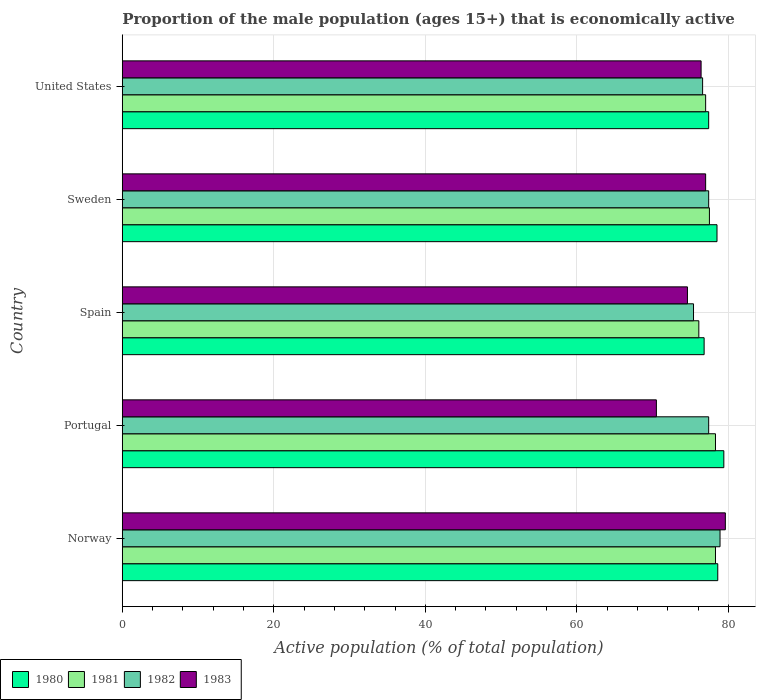How many groups of bars are there?
Offer a very short reply. 5. Are the number of bars per tick equal to the number of legend labels?
Ensure brevity in your answer.  Yes. How many bars are there on the 1st tick from the bottom?
Provide a short and direct response. 4. What is the proportion of the male population that is economically active in 1980 in Portugal?
Your response must be concise. 79.4. Across all countries, what is the maximum proportion of the male population that is economically active in 1981?
Provide a short and direct response. 78.3. Across all countries, what is the minimum proportion of the male population that is economically active in 1980?
Your answer should be compact. 76.8. In which country was the proportion of the male population that is economically active in 1981 maximum?
Ensure brevity in your answer.  Norway. What is the total proportion of the male population that is economically active in 1982 in the graph?
Give a very brief answer. 385.7. What is the difference between the proportion of the male population that is economically active in 1981 in Portugal and that in Spain?
Keep it short and to the point. 2.2. What is the difference between the proportion of the male population that is economically active in 1982 in Norway and the proportion of the male population that is economically active in 1983 in Spain?
Offer a terse response. 4.3. What is the average proportion of the male population that is economically active in 1981 per country?
Offer a very short reply. 77.44. What is the difference between the proportion of the male population that is economically active in 1980 and proportion of the male population that is economically active in 1982 in Sweden?
Keep it short and to the point. 1.1. In how many countries, is the proportion of the male population that is economically active in 1983 greater than 20 %?
Provide a short and direct response. 5. What is the ratio of the proportion of the male population that is economically active in 1980 in Spain to that in United States?
Your answer should be very brief. 0.99. Is the proportion of the male population that is economically active in 1980 in Norway less than that in Spain?
Keep it short and to the point. No. What is the difference between the highest and the second highest proportion of the male population that is economically active in 1982?
Make the answer very short. 1.5. Is the sum of the proportion of the male population that is economically active in 1980 in Norway and Spain greater than the maximum proportion of the male population that is economically active in 1981 across all countries?
Offer a terse response. Yes. Is it the case that in every country, the sum of the proportion of the male population that is economically active in 1982 and proportion of the male population that is economically active in 1983 is greater than the sum of proportion of the male population that is economically active in 1981 and proportion of the male population that is economically active in 1980?
Give a very brief answer. No. What does the 4th bar from the bottom in Norway represents?
Offer a very short reply. 1983. How many countries are there in the graph?
Provide a succinct answer. 5. What is the difference between two consecutive major ticks on the X-axis?
Ensure brevity in your answer.  20. Are the values on the major ticks of X-axis written in scientific E-notation?
Your answer should be very brief. No. Does the graph contain any zero values?
Provide a short and direct response. No. Where does the legend appear in the graph?
Your answer should be very brief. Bottom left. How many legend labels are there?
Offer a very short reply. 4. What is the title of the graph?
Your answer should be very brief. Proportion of the male population (ages 15+) that is economically active. What is the label or title of the X-axis?
Keep it short and to the point. Active population (% of total population). What is the Active population (% of total population) of 1980 in Norway?
Your answer should be compact. 78.6. What is the Active population (% of total population) in 1981 in Norway?
Provide a short and direct response. 78.3. What is the Active population (% of total population) in 1982 in Norway?
Offer a terse response. 78.9. What is the Active population (% of total population) of 1983 in Norway?
Your answer should be very brief. 79.6. What is the Active population (% of total population) of 1980 in Portugal?
Offer a very short reply. 79.4. What is the Active population (% of total population) of 1981 in Portugal?
Make the answer very short. 78.3. What is the Active population (% of total population) of 1982 in Portugal?
Offer a very short reply. 77.4. What is the Active population (% of total population) in 1983 in Portugal?
Provide a succinct answer. 70.5. What is the Active population (% of total population) in 1980 in Spain?
Your answer should be compact. 76.8. What is the Active population (% of total population) of 1981 in Spain?
Keep it short and to the point. 76.1. What is the Active population (% of total population) of 1982 in Spain?
Offer a very short reply. 75.4. What is the Active population (% of total population) of 1983 in Spain?
Offer a terse response. 74.6. What is the Active population (% of total population) in 1980 in Sweden?
Keep it short and to the point. 78.5. What is the Active population (% of total population) of 1981 in Sweden?
Keep it short and to the point. 77.5. What is the Active population (% of total population) in 1982 in Sweden?
Keep it short and to the point. 77.4. What is the Active population (% of total population) of 1983 in Sweden?
Keep it short and to the point. 77. What is the Active population (% of total population) of 1980 in United States?
Your response must be concise. 77.4. What is the Active population (% of total population) in 1981 in United States?
Offer a terse response. 77. What is the Active population (% of total population) in 1982 in United States?
Your answer should be compact. 76.6. What is the Active population (% of total population) of 1983 in United States?
Make the answer very short. 76.4. Across all countries, what is the maximum Active population (% of total population) in 1980?
Keep it short and to the point. 79.4. Across all countries, what is the maximum Active population (% of total population) in 1981?
Provide a short and direct response. 78.3. Across all countries, what is the maximum Active population (% of total population) of 1982?
Offer a very short reply. 78.9. Across all countries, what is the maximum Active population (% of total population) of 1983?
Give a very brief answer. 79.6. Across all countries, what is the minimum Active population (% of total population) in 1980?
Keep it short and to the point. 76.8. Across all countries, what is the minimum Active population (% of total population) in 1981?
Your answer should be very brief. 76.1. Across all countries, what is the minimum Active population (% of total population) in 1982?
Give a very brief answer. 75.4. Across all countries, what is the minimum Active population (% of total population) of 1983?
Keep it short and to the point. 70.5. What is the total Active population (% of total population) in 1980 in the graph?
Your response must be concise. 390.7. What is the total Active population (% of total population) in 1981 in the graph?
Keep it short and to the point. 387.2. What is the total Active population (% of total population) in 1982 in the graph?
Your answer should be very brief. 385.7. What is the total Active population (% of total population) of 1983 in the graph?
Provide a short and direct response. 378.1. What is the difference between the Active population (% of total population) in 1980 in Norway and that in Portugal?
Offer a very short reply. -0.8. What is the difference between the Active population (% of total population) of 1981 in Norway and that in Portugal?
Offer a terse response. 0. What is the difference between the Active population (% of total population) in 1982 in Norway and that in Portugal?
Give a very brief answer. 1.5. What is the difference between the Active population (% of total population) in 1982 in Norway and that in Spain?
Make the answer very short. 3.5. What is the difference between the Active population (% of total population) in 1983 in Norway and that in Spain?
Provide a succinct answer. 5. What is the difference between the Active population (% of total population) of 1980 in Norway and that in Sweden?
Provide a succinct answer. 0.1. What is the difference between the Active population (% of total population) in 1981 in Norway and that in Sweden?
Make the answer very short. 0.8. What is the difference between the Active population (% of total population) in 1982 in Norway and that in Sweden?
Your answer should be compact. 1.5. What is the difference between the Active population (% of total population) in 1983 in Norway and that in Sweden?
Your answer should be compact. 2.6. What is the difference between the Active population (% of total population) in 1981 in Norway and that in United States?
Offer a very short reply. 1.3. What is the difference between the Active population (% of total population) in 1983 in Norway and that in United States?
Your answer should be very brief. 3.2. What is the difference between the Active population (% of total population) of 1980 in Portugal and that in Spain?
Your answer should be compact. 2.6. What is the difference between the Active population (% of total population) of 1981 in Portugal and that in Sweden?
Your answer should be compact. 0.8. What is the difference between the Active population (% of total population) in 1983 in Portugal and that in Sweden?
Provide a succinct answer. -6.5. What is the difference between the Active population (% of total population) of 1980 in Portugal and that in United States?
Your answer should be very brief. 2. What is the difference between the Active population (% of total population) of 1981 in Portugal and that in United States?
Provide a succinct answer. 1.3. What is the difference between the Active population (% of total population) in 1982 in Portugal and that in United States?
Provide a short and direct response. 0.8. What is the difference between the Active population (% of total population) of 1982 in Spain and that in Sweden?
Make the answer very short. -2. What is the difference between the Active population (% of total population) in 1980 in Spain and that in United States?
Give a very brief answer. -0.6. What is the difference between the Active population (% of total population) of 1981 in Spain and that in United States?
Make the answer very short. -0.9. What is the difference between the Active population (% of total population) of 1981 in Sweden and that in United States?
Keep it short and to the point. 0.5. What is the difference between the Active population (% of total population) in 1980 in Norway and the Active population (% of total population) in 1982 in Portugal?
Your answer should be compact. 1.2. What is the difference between the Active population (% of total population) in 1981 in Norway and the Active population (% of total population) in 1982 in Portugal?
Your answer should be compact. 0.9. What is the difference between the Active population (% of total population) of 1981 in Norway and the Active population (% of total population) of 1983 in Portugal?
Offer a very short reply. 7.8. What is the difference between the Active population (% of total population) of 1980 in Norway and the Active population (% of total population) of 1981 in Spain?
Your response must be concise. 2.5. What is the difference between the Active population (% of total population) of 1980 in Norway and the Active population (% of total population) of 1983 in Spain?
Your answer should be compact. 4. What is the difference between the Active population (% of total population) of 1981 in Norway and the Active population (% of total population) of 1983 in Spain?
Make the answer very short. 3.7. What is the difference between the Active population (% of total population) of 1980 in Norway and the Active population (% of total population) of 1982 in Sweden?
Your answer should be very brief. 1.2. What is the difference between the Active population (% of total population) of 1981 in Norway and the Active population (% of total population) of 1983 in Sweden?
Provide a short and direct response. 1.3. What is the difference between the Active population (% of total population) in 1980 in Norway and the Active population (% of total population) in 1981 in United States?
Offer a very short reply. 1.6. What is the difference between the Active population (% of total population) of 1980 in Norway and the Active population (% of total population) of 1982 in United States?
Offer a very short reply. 2. What is the difference between the Active population (% of total population) of 1980 in Norway and the Active population (% of total population) of 1983 in United States?
Your answer should be compact. 2.2. What is the difference between the Active population (% of total population) of 1981 in Norway and the Active population (% of total population) of 1983 in United States?
Provide a short and direct response. 1.9. What is the difference between the Active population (% of total population) of 1980 in Portugal and the Active population (% of total population) of 1981 in Spain?
Your response must be concise. 3.3. What is the difference between the Active population (% of total population) of 1980 in Portugal and the Active population (% of total population) of 1982 in Spain?
Give a very brief answer. 4. What is the difference between the Active population (% of total population) of 1980 in Portugal and the Active population (% of total population) of 1981 in Sweden?
Give a very brief answer. 1.9. What is the difference between the Active population (% of total population) in 1980 in Portugal and the Active population (% of total population) in 1983 in Sweden?
Ensure brevity in your answer.  2.4. What is the difference between the Active population (% of total population) of 1981 in Portugal and the Active population (% of total population) of 1983 in Sweden?
Your answer should be compact. 1.3. What is the difference between the Active population (% of total population) of 1982 in Portugal and the Active population (% of total population) of 1983 in Sweden?
Your response must be concise. 0.4. What is the difference between the Active population (% of total population) in 1980 in Portugal and the Active population (% of total population) in 1981 in United States?
Give a very brief answer. 2.4. What is the difference between the Active population (% of total population) of 1980 in Portugal and the Active population (% of total population) of 1982 in United States?
Provide a short and direct response. 2.8. What is the difference between the Active population (% of total population) in 1980 in Portugal and the Active population (% of total population) in 1983 in United States?
Provide a short and direct response. 3. What is the difference between the Active population (% of total population) in 1981 in Portugal and the Active population (% of total population) in 1982 in United States?
Offer a terse response. 1.7. What is the difference between the Active population (% of total population) of 1980 in Spain and the Active population (% of total population) of 1982 in Sweden?
Keep it short and to the point. -0.6. What is the difference between the Active population (% of total population) in 1981 in Spain and the Active population (% of total population) in 1982 in Sweden?
Provide a succinct answer. -1.3. What is the difference between the Active population (% of total population) of 1981 in Spain and the Active population (% of total population) of 1983 in Sweden?
Make the answer very short. -0.9. What is the difference between the Active population (% of total population) in 1982 in Spain and the Active population (% of total population) in 1983 in Sweden?
Make the answer very short. -1.6. What is the difference between the Active population (% of total population) in 1980 in Spain and the Active population (% of total population) in 1983 in United States?
Give a very brief answer. 0.4. What is the difference between the Active population (% of total population) in 1981 in Spain and the Active population (% of total population) in 1982 in United States?
Provide a succinct answer. -0.5. What is the difference between the Active population (% of total population) in 1980 in Sweden and the Active population (% of total population) in 1983 in United States?
Your answer should be very brief. 2.1. What is the difference between the Active population (% of total population) of 1981 in Sweden and the Active population (% of total population) of 1982 in United States?
Provide a short and direct response. 0.9. What is the difference between the Active population (% of total population) of 1982 in Sweden and the Active population (% of total population) of 1983 in United States?
Keep it short and to the point. 1. What is the average Active population (% of total population) in 1980 per country?
Provide a short and direct response. 78.14. What is the average Active population (% of total population) in 1981 per country?
Provide a succinct answer. 77.44. What is the average Active population (% of total population) of 1982 per country?
Ensure brevity in your answer.  77.14. What is the average Active population (% of total population) in 1983 per country?
Ensure brevity in your answer.  75.62. What is the difference between the Active population (% of total population) of 1980 and Active population (% of total population) of 1983 in Norway?
Your answer should be very brief. -1. What is the difference between the Active population (% of total population) in 1981 and Active population (% of total population) in 1982 in Norway?
Provide a short and direct response. -0.6. What is the difference between the Active population (% of total population) of 1981 and Active population (% of total population) of 1983 in Norway?
Provide a succinct answer. -1.3. What is the difference between the Active population (% of total population) in 1980 and Active population (% of total population) in 1981 in Portugal?
Your response must be concise. 1.1. What is the difference between the Active population (% of total population) in 1980 and Active population (% of total population) in 1983 in Portugal?
Provide a short and direct response. 8.9. What is the difference between the Active population (% of total population) of 1981 and Active population (% of total population) of 1982 in Portugal?
Ensure brevity in your answer.  0.9. What is the difference between the Active population (% of total population) in 1981 and Active population (% of total population) in 1983 in Portugal?
Your response must be concise. 7.8. What is the difference between the Active population (% of total population) of 1982 and Active population (% of total population) of 1983 in Portugal?
Provide a succinct answer. 6.9. What is the difference between the Active population (% of total population) of 1980 and Active population (% of total population) of 1983 in Spain?
Your response must be concise. 2.2. What is the difference between the Active population (% of total population) of 1981 and Active population (% of total population) of 1982 in Spain?
Your response must be concise. 0.7. What is the difference between the Active population (% of total population) of 1981 and Active population (% of total population) of 1983 in Spain?
Your response must be concise. 1.5. What is the difference between the Active population (% of total population) in 1982 and Active population (% of total population) in 1983 in Spain?
Provide a succinct answer. 0.8. What is the difference between the Active population (% of total population) of 1980 and Active population (% of total population) of 1981 in Sweden?
Provide a short and direct response. 1. What is the difference between the Active population (% of total population) of 1980 and Active population (% of total population) of 1983 in Sweden?
Provide a short and direct response. 1.5. What is the difference between the Active population (% of total population) of 1981 and Active population (% of total population) of 1982 in Sweden?
Your response must be concise. 0.1. What is the difference between the Active population (% of total population) of 1981 and Active population (% of total population) of 1983 in Sweden?
Make the answer very short. 0.5. What is the difference between the Active population (% of total population) of 1982 and Active population (% of total population) of 1983 in Sweden?
Keep it short and to the point. 0.4. What is the difference between the Active population (% of total population) of 1981 and Active population (% of total population) of 1983 in United States?
Offer a very short reply. 0.6. What is the difference between the Active population (% of total population) in 1982 and Active population (% of total population) in 1983 in United States?
Offer a very short reply. 0.2. What is the ratio of the Active population (% of total population) of 1980 in Norway to that in Portugal?
Ensure brevity in your answer.  0.99. What is the ratio of the Active population (% of total population) in 1982 in Norway to that in Portugal?
Keep it short and to the point. 1.02. What is the ratio of the Active population (% of total population) in 1983 in Norway to that in Portugal?
Provide a short and direct response. 1.13. What is the ratio of the Active population (% of total population) in 1980 in Norway to that in Spain?
Offer a very short reply. 1.02. What is the ratio of the Active population (% of total population) in 1981 in Norway to that in Spain?
Offer a terse response. 1.03. What is the ratio of the Active population (% of total population) of 1982 in Norway to that in Spain?
Provide a short and direct response. 1.05. What is the ratio of the Active population (% of total population) in 1983 in Norway to that in Spain?
Your answer should be very brief. 1.07. What is the ratio of the Active population (% of total population) of 1980 in Norway to that in Sweden?
Provide a short and direct response. 1. What is the ratio of the Active population (% of total population) of 1981 in Norway to that in Sweden?
Provide a short and direct response. 1.01. What is the ratio of the Active population (% of total population) in 1982 in Norway to that in Sweden?
Your answer should be compact. 1.02. What is the ratio of the Active population (% of total population) of 1983 in Norway to that in Sweden?
Offer a very short reply. 1.03. What is the ratio of the Active population (% of total population) of 1980 in Norway to that in United States?
Your answer should be compact. 1.02. What is the ratio of the Active population (% of total population) of 1981 in Norway to that in United States?
Keep it short and to the point. 1.02. What is the ratio of the Active population (% of total population) of 1983 in Norway to that in United States?
Your answer should be compact. 1.04. What is the ratio of the Active population (% of total population) of 1980 in Portugal to that in Spain?
Your answer should be compact. 1.03. What is the ratio of the Active population (% of total population) of 1981 in Portugal to that in Spain?
Give a very brief answer. 1.03. What is the ratio of the Active population (% of total population) in 1982 in Portugal to that in Spain?
Give a very brief answer. 1.03. What is the ratio of the Active population (% of total population) in 1983 in Portugal to that in Spain?
Offer a terse response. 0.94. What is the ratio of the Active population (% of total population) of 1980 in Portugal to that in Sweden?
Your answer should be compact. 1.01. What is the ratio of the Active population (% of total population) of 1981 in Portugal to that in Sweden?
Offer a very short reply. 1.01. What is the ratio of the Active population (% of total population) of 1982 in Portugal to that in Sweden?
Your answer should be compact. 1. What is the ratio of the Active population (% of total population) in 1983 in Portugal to that in Sweden?
Provide a short and direct response. 0.92. What is the ratio of the Active population (% of total population) in 1980 in Portugal to that in United States?
Your response must be concise. 1.03. What is the ratio of the Active population (% of total population) in 1981 in Portugal to that in United States?
Provide a succinct answer. 1.02. What is the ratio of the Active population (% of total population) of 1982 in Portugal to that in United States?
Make the answer very short. 1.01. What is the ratio of the Active population (% of total population) of 1983 in Portugal to that in United States?
Offer a very short reply. 0.92. What is the ratio of the Active population (% of total population) in 1980 in Spain to that in Sweden?
Provide a succinct answer. 0.98. What is the ratio of the Active population (% of total population) in 1981 in Spain to that in Sweden?
Ensure brevity in your answer.  0.98. What is the ratio of the Active population (% of total population) of 1982 in Spain to that in Sweden?
Offer a very short reply. 0.97. What is the ratio of the Active population (% of total population) in 1983 in Spain to that in Sweden?
Your answer should be compact. 0.97. What is the ratio of the Active population (% of total population) in 1980 in Spain to that in United States?
Ensure brevity in your answer.  0.99. What is the ratio of the Active population (% of total population) of 1981 in Spain to that in United States?
Your answer should be compact. 0.99. What is the ratio of the Active population (% of total population) in 1982 in Spain to that in United States?
Your answer should be compact. 0.98. What is the ratio of the Active population (% of total population) in 1983 in Spain to that in United States?
Keep it short and to the point. 0.98. What is the ratio of the Active population (% of total population) of 1980 in Sweden to that in United States?
Offer a very short reply. 1.01. What is the ratio of the Active population (% of total population) in 1981 in Sweden to that in United States?
Your response must be concise. 1.01. What is the ratio of the Active population (% of total population) in 1982 in Sweden to that in United States?
Provide a succinct answer. 1.01. What is the ratio of the Active population (% of total population) of 1983 in Sweden to that in United States?
Make the answer very short. 1.01. What is the difference between the highest and the second highest Active population (% of total population) in 1980?
Provide a short and direct response. 0.8. What is the difference between the highest and the second highest Active population (% of total population) in 1981?
Your response must be concise. 0. What is the difference between the highest and the second highest Active population (% of total population) in 1982?
Ensure brevity in your answer.  1.5. 